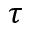<formula> <loc_0><loc_0><loc_500><loc_500>\tau</formula> 